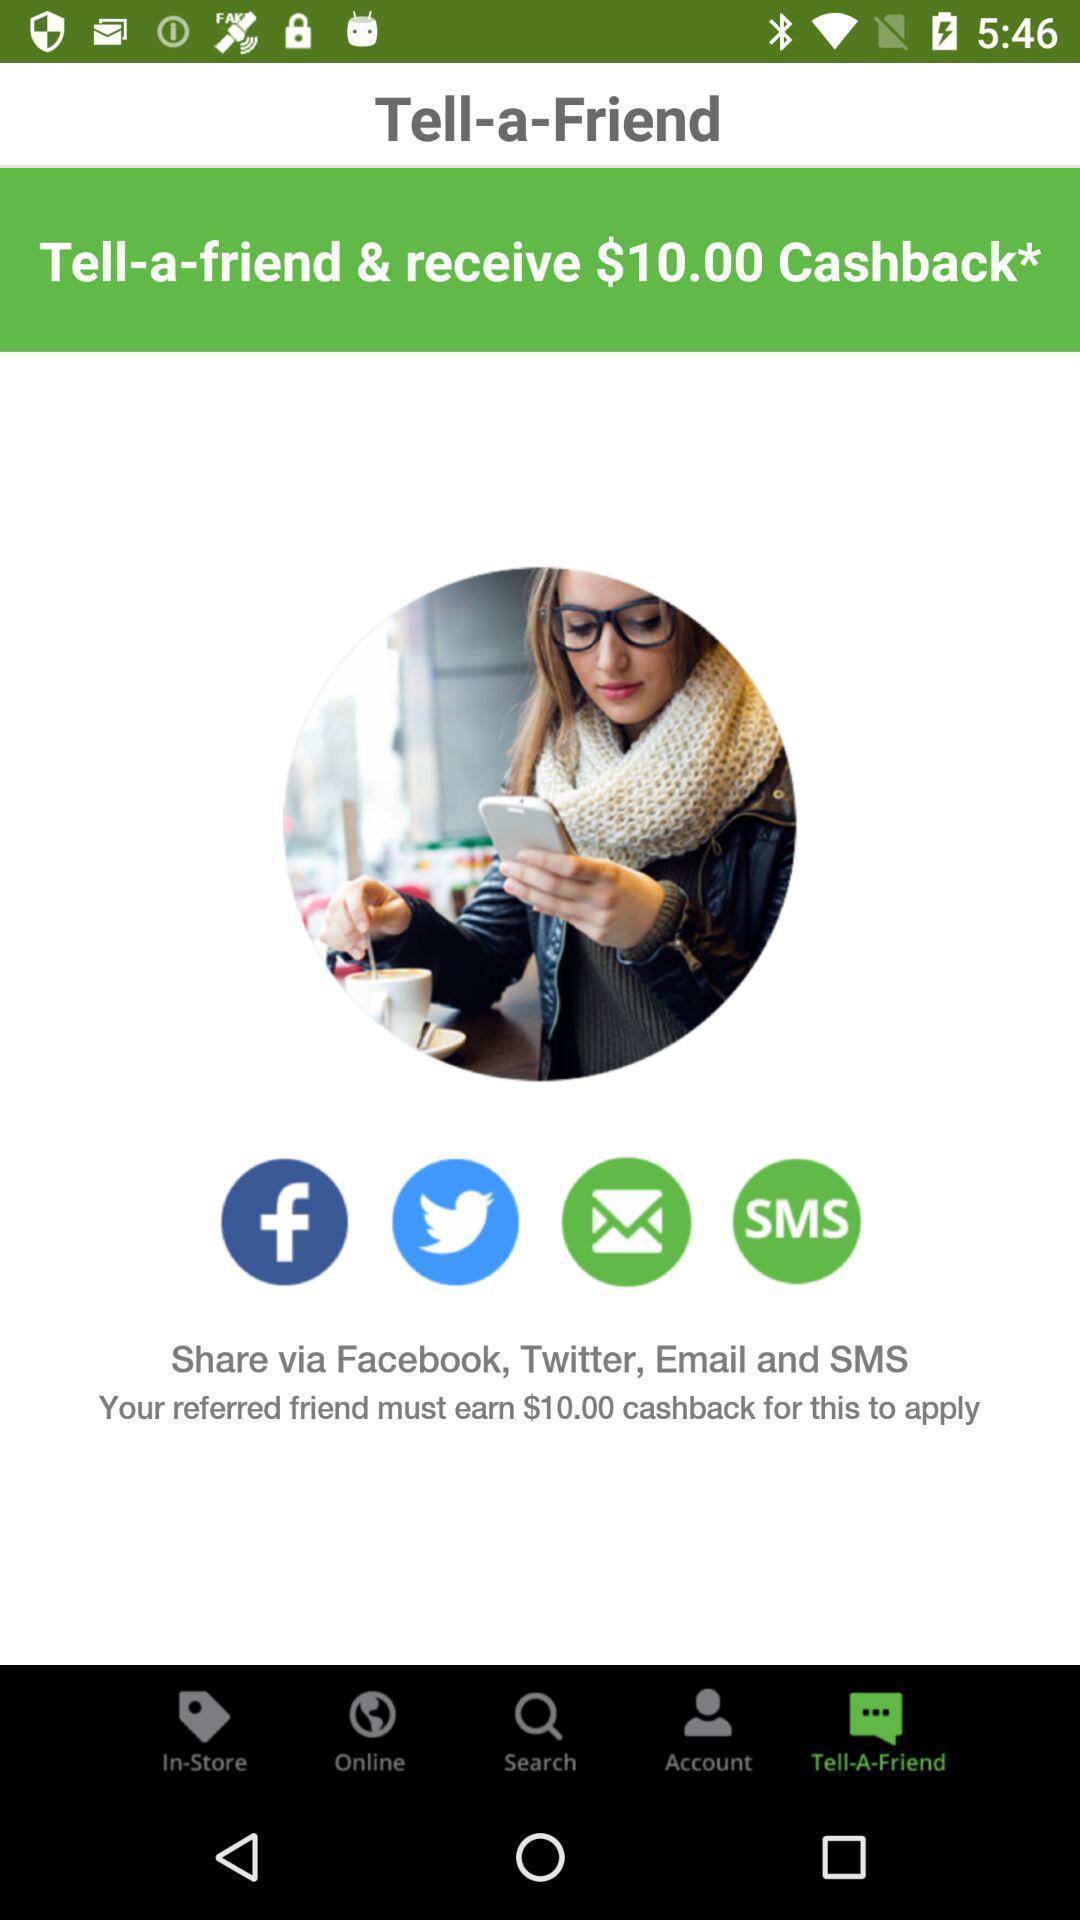Give me a summary of this screen capture. Page displaying various social apps. 